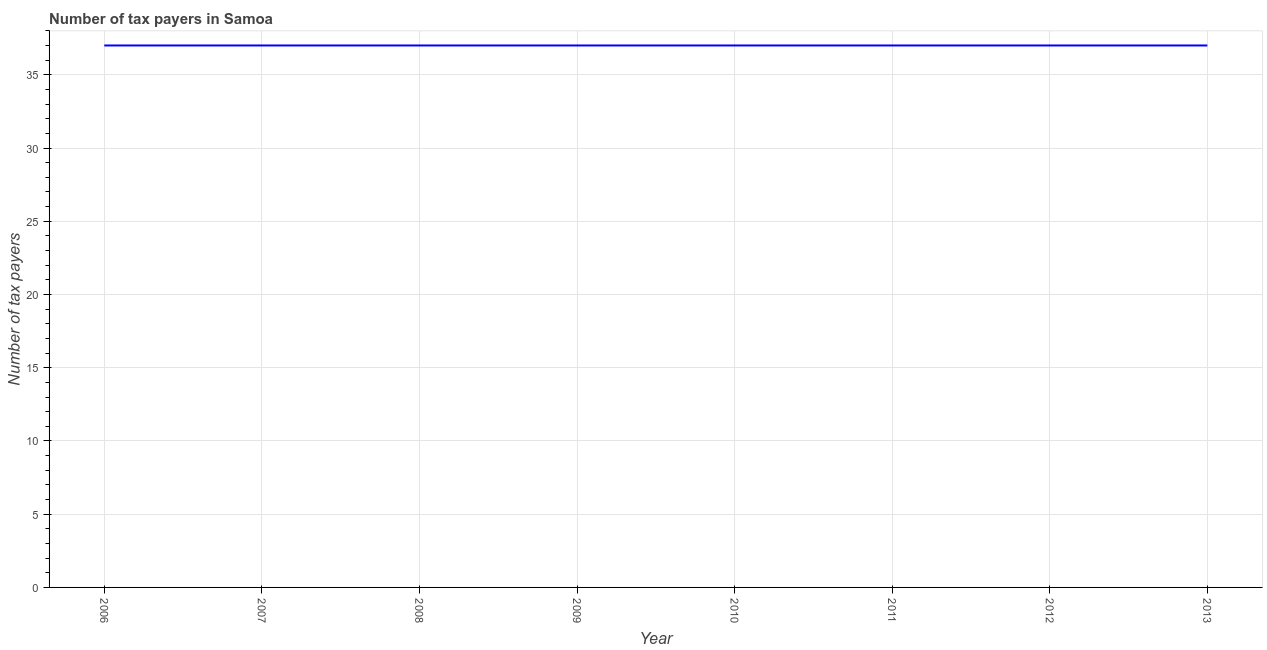What is the number of tax payers in 2011?
Make the answer very short. 37. Across all years, what is the maximum number of tax payers?
Offer a terse response. 37. Across all years, what is the minimum number of tax payers?
Provide a short and direct response. 37. In which year was the number of tax payers minimum?
Offer a terse response. 2006. What is the sum of the number of tax payers?
Keep it short and to the point. 296. What is the average number of tax payers per year?
Make the answer very short. 37. What is the median number of tax payers?
Keep it short and to the point. 37. In how many years, is the number of tax payers greater than 7 ?
Your answer should be compact. 8. Is the difference between the number of tax payers in 2006 and 2007 greater than the difference between any two years?
Offer a terse response. Yes. What is the difference between the highest and the second highest number of tax payers?
Make the answer very short. 0. What is the difference between the highest and the lowest number of tax payers?
Your answer should be very brief. 0. In how many years, is the number of tax payers greater than the average number of tax payers taken over all years?
Provide a short and direct response. 0. Does the number of tax payers monotonically increase over the years?
Offer a very short reply. No. How many lines are there?
Your response must be concise. 1. How many years are there in the graph?
Offer a terse response. 8. Are the values on the major ticks of Y-axis written in scientific E-notation?
Keep it short and to the point. No. What is the title of the graph?
Your response must be concise. Number of tax payers in Samoa. What is the label or title of the X-axis?
Make the answer very short. Year. What is the label or title of the Y-axis?
Offer a very short reply. Number of tax payers. What is the Number of tax payers of 2006?
Provide a succinct answer. 37. What is the Number of tax payers of 2008?
Offer a terse response. 37. What is the Number of tax payers in 2009?
Provide a short and direct response. 37. What is the Number of tax payers in 2010?
Give a very brief answer. 37. What is the Number of tax payers of 2011?
Your answer should be compact. 37. What is the Number of tax payers in 2012?
Give a very brief answer. 37. What is the difference between the Number of tax payers in 2006 and 2009?
Provide a short and direct response. 0. What is the difference between the Number of tax payers in 2006 and 2010?
Your answer should be very brief. 0. What is the difference between the Number of tax payers in 2006 and 2011?
Your answer should be very brief. 0. What is the difference between the Number of tax payers in 2006 and 2012?
Ensure brevity in your answer.  0. What is the difference between the Number of tax payers in 2007 and 2009?
Your answer should be very brief. 0. What is the difference between the Number of tax payers in 2007 and 2010?
Keep it short and to the point. 0. What is the difference between the Number of tax payers in 2007 and 2012?
Make the answer very short. 0. What is the difference between the Number of tax payers in 2009 and 2010?
Keep it short and to the point. 0. What is the difference between the Number of tax payers in 2009 and 2011?
Your response must be concise. 0. What is the difference between the Number of tax payers in 2009 and 2012?
Your answer should be very brief. 0. What is the ratio of the Number of tax payers in 2006 to that in 2007?
Your answer should be compact. 1. What is the ratio of the Number of tax payers in 2006 to that in 2008?
Your response must be concise. 1. What is the ratio of the Number of tax payers in 2006 to that in 2009?
Keep it short and to the point. 1. What is the ratio of the Number of tax payers in 2006 to that in 2012?
Make the answer very short. 1. What is the ratio of the Number of tax payers in 2006 to that in 2013?
Give a very brief answer. 1. What is the ratio of the Number of tax payers in 2007 to that in 2010?
Give a very brief answer. 1. What is the ratio of the Number of tax payers in 2007 to that in 2011?
Keep it short and to the point. 1. What is the ratio of the Number of tax payers in 2007 to that in 2012?
Ensure brevity in your answer.  1. What is the ratio of the Number of tax payers in 2008 to that in 2009?
Make the answer very short. 1. What is the ratio of the Number of tax payers in 2008 to that in 2010?
Keep it short and to the point. 1. What is the ratio of the Number of tax payers in 2008 to that in 2011?
Your answer should be very brief. 1. What is the ratio of the Number of tax payers in 2008 to that in 2012?
Your answer should be compact. 1. What is the ratio of the Number of tax payers in 2009 to that in 2010?
Give a very brief answer. 1. What is the ratio of the Number of tax payers in 2009 to that in 2011?
Ensure brevity in your answer.  1. What is the ratio of the Number of tax payers in 2011 to that in 2012?
Make the answer very short. 1. What is the ratio of the Number of tax payers in 2011 to that in 2013?
Ensure brevity in your answer.  1. 